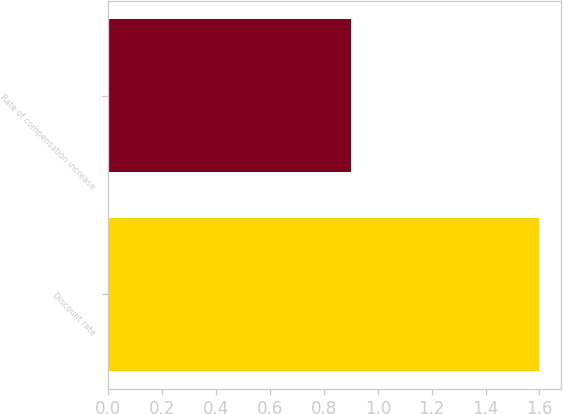Convert chart. <chart><loc_0><loc_0><loc_500><loc_500><bar_chart><fcel>Discount rate<fcel>Rate of compensation increase<nl><fcel>1.6<fcel>0.9<nl></chart> 